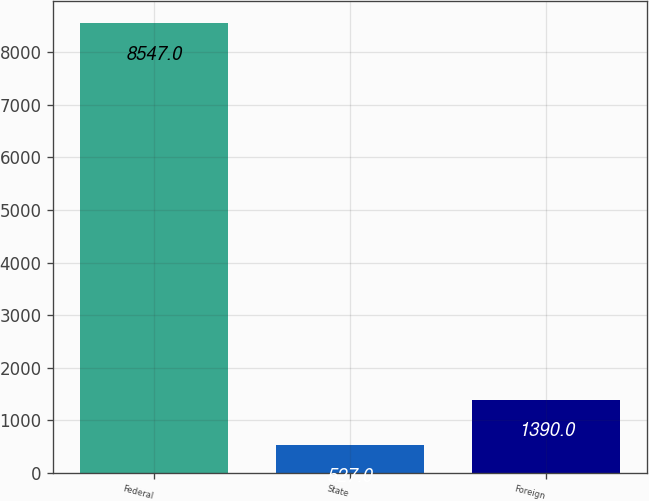<chart> <loc_0><loc_0><loc_500><loc_500><bar_chart><fcel>Federal<fcel>State<fcel>Foreign<nl><fcel>8547<fcel>527<fcel>1390<nl></chart> 